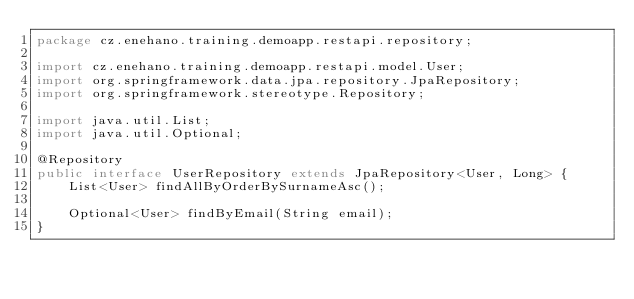<code> <loc_0><loc_0><loc_500><loc_500><_Java_>package cz.enehano.training.demoapp.restapi.repository;

import cz.enehano.training.demoapp.restapi.model.User;
import org.springframework.data.jpa.repository.JpaRepository;
import org.springframework.stereotype.Repository;

import java.util.List;
import java.util.Optional;

@Repository
public interface UserRepository extends JpaRepository<User, Long> {
    List<User> findAllByOrderBySurnameAsc();

    Optional<User> findByEmail(String email);
}</code> 